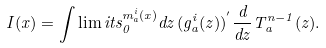Convert formula to latex. <formula><loc_0><loc_0><loc_500><loc_500>I ( x ) = \int \lim i t s _ { 0 } ^ { m _ { a } ^ { i } ( x ) } d z \, ( g _ { a } ^ { i } ( z ) ) ^ { ^ { \prime } } \frac { d } { d z } T _ { a } ^ { n - 1 } ( z ) .</formula> 